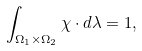<formula> <loc_0><loc_0><loc_500><loc_500>\int _ { \Omega _ { 1 } \times \Omega _ { 2 } } \chi \cdot d \lambda = 1 ,</formula> 